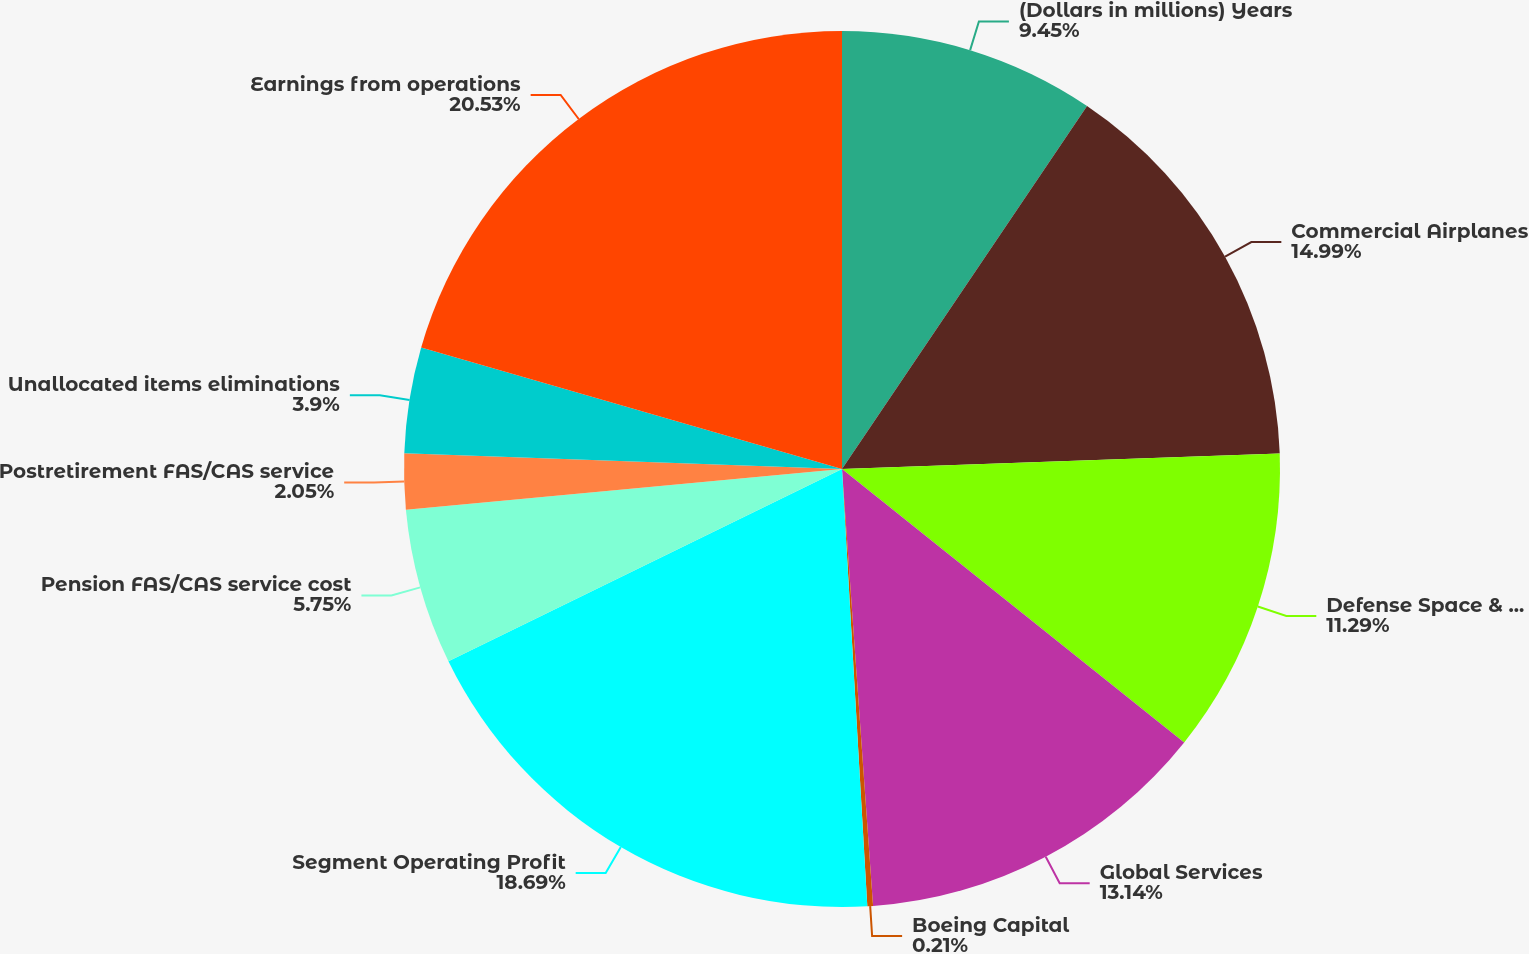Convert chart. <chart><loc_0><loc_0><loc_500><loc_500><pie_chart><fcel>(Dollars in millions) Years<fcel>Commercial Airplanes<fcel>Defense Space & Security<fcel>Global Services<fcel>Boeing Capital<fcel>Segment Operating Profit<fcel>Pension FAS/CAS service cost<fcel>Postretirement FAS/CAS service<fcel>Unallocated items eliminations<fcel>Earnings from operations<nl><fcel>9.45%<fcel>14.99%<fcel>11.29%<fcel>13.14%<fcel>0.21%<fcel>18.69%<fcel>5.75%<fcel>2.05%<fcel>3.9%<fcel>20.53%<nl></chart> 